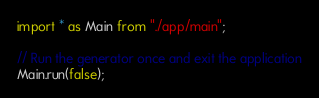Convert code to text. <code><loc_0><loc_0><loc_500><loc_500><_TypeScript_>import * as Main from "./app/main";

// Run the generator once and exit the application
Main.run(false);
</code> 